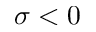<formula> <loc_0><loc_0><loc_500><loc_500>\sigma < 0</formula> 